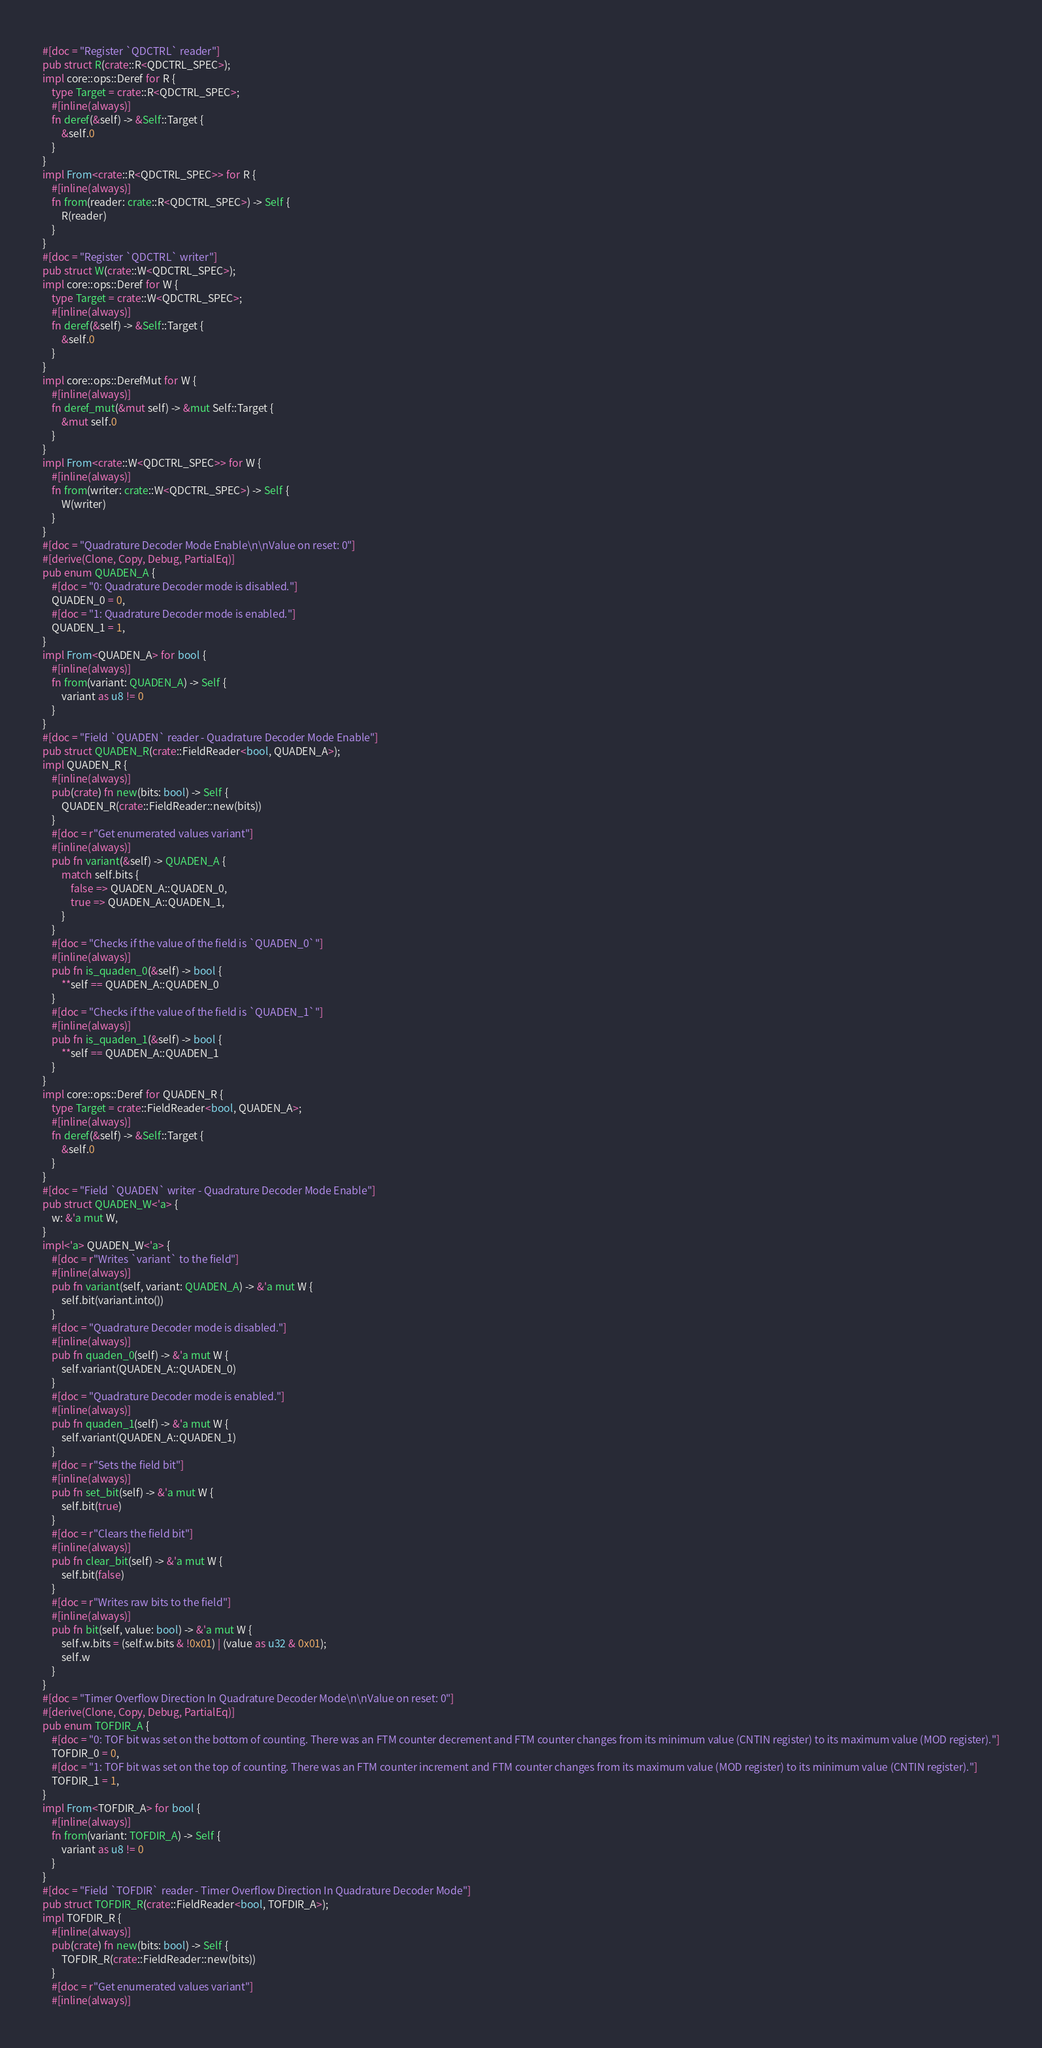Convert code to text. <code><loc_0><loc_0><loc_500><loc_500><_Rust_>#[doc = "Register `QDCTRL` reader"]
pub struct R(crate::R<QDCTRL_SPEC>);
impl core::ops::Deref for R {
    type Target = crate::R<QDCTRL_SPEC>;
    #[inline(always)]
    fn deref(&self) -> &Self::Target {
        &self.0
    }
}
impl From<crate::R<QDCTRL_SPEC>> for R {
    #[inline(always)]
    fn from(reader: crate::R<QDCTRL_SPEC>) -> Self {
        R(reader)
    }
}
#[doc = "Register `QDCTRL` writer"]
pub struct W(crate::W<QDCTRL_SPEC>);
impl core::ops::Deref for W {
    type Target = crate::W<QDCTRL_SPEC>;
    #[inline(always)]
    fn deref(&self) -> &Self::Target {
        &self.0
    }
}
impl core::ops::DerefMut for W {
    #[inline(always)]
    fn deref_mut(&mut self) -> &mut Self::Target {
        &mut self.0
    }
}
impl From<crate::W<QDCTRL_SPEC>> for W {
    #[inline(always)]
    fn from(writer: crate::W<QDCTRL_SPEC>) -> Self {
        W(writer)
    }
}
#[doc = "Quadrature Decoder Mode Enable\n\nValue on reset: 0"]
#[derive(Clone, Copy, Debug, PartialEq)]
pub enum QUADEN_A {
    #[doc = "0: Quadrature Decoder mode is disabled."]
    QUADEN_0 = 0,
    #[doc = "1: Quadrature Decoder mode is enabled."]
    QUADEN_1 = 1,
}
impl From<QUADEN_A> for bool {
    #[inline(always)]
    fn from(variant: QUADEN_A) -> Self {
        variant as u8 != 0
    }
}
#[doc = "Field `QUADEN` reader - Quadrature Decoder Mode Enable"]
pub struct QUADEN_R(crate::FieldReader<bool, QUADEN_A>);
impl QUADEN_R {
    #[inline(always)]
    pub(crate) fn new(bits: bool) -> Self {
        QUADEN_R(crate::FieldReader::new(bits))
    }
    #[doc = r"Get enumerated values variant"]
    #[inline(always)]
    pub fn variant(&self) -> QUADEN_A {
        match self.bits {
            false => QUADEN_A::QUADEN_0,
            true => QUADEN_A::QUADEN_1,
        }
    }
    #[doc = "Checks if the value of the field is `QUADEN_0`"]
    #[inline(always)]
    pub fn is_quaden_0(&self) -> bool {
        **self == QUADEN_A::QUADEN_0
    }
    #[doc = "Checks if the value of the field is `QUADEN_1`"]
    #[inline(always)]
    pub fn is_quaden_1(&self) -> bool {
        **self == QUADEN_A::QUADEN_1
    }
}
impl core::ops::Deref for QUADEN_R {
    type Target = crate::FieldReader<bool, QUADEN_A>;
    #[inline(always)]
    fn deref(&self) -> &Self::Target {
        &self.0
    }
}
#[doc = "Field `QUADEN` writer - Quadrature Decoder Mode Enable"]
pub struct QUADEN_W<'a> {
    w: &'a mut W,
}
impl<'a> QUADEN_W<'a> {
    #[doc = r"Writes `variant` to the field"]
    #[inline(always)]
    pub fn variant(self, variant: QUADEN_A) -> &'a mut W {
        self.bit(variant.into())
    }
    #[doc = "Quadrature Decoder mode is disabled."]
    #[inline(always)]
    pub fn quaden_0(self) -> &'a mut W {
        self.variant(QUADEN_A::QUADEN_0)
    }
    #[doc = "Quadrature Decoder mode is enabled."]
    #[inline(always)]
    pub fn quaden_1(self) -> &'a mut W {
        self.variant(QUADEN_A::QUADEN_1)
    }
    #[doc = r"Sets the field bit"]
    #[inline(always)]
    pub fn set_bit(self) -> &'a mut W {
        self.bit(true)
    }
    #[doc = r"Clears the field bit"]
    #[inline(always)]
    pub fn clear_bit(self) -> &'a mut W {
        self.bit(false)
    }
    #[doc = r"Writes raw bits to the field"]
    #[inline(always)]
    pub fn bit(self, value: bool) -> &'a mut W {
        self.w.bits = (self.w.bits & !0x01) | (value as u32 & 0x01);
        self.w
    }
}
#[doc = "Timer Overflow Direction In Quadrature Decoder Mode\n\nValue on reset: 0"]
#[derive(Clone, Copy, Debug, PartialEq)]
pub enum TOFDIR_A {
    #[doc = "0: TOF bit was set on the bottom of counting. There was an FTM counter decrement and FTM counter changes from its minimum value (CNTIN register) to its maximum value (MOD register)."]
    TOFDIR_0 = 0,
    #[doc = "1: TOF bit was set on the top of counting. There was an FTM counter increment and FTM counter changes from its maximum value (MOD register) to its minimum value (CNTIN register)."]
    TOFDIR_1 = 1,
}
impl From<TOFDIR_A> for bool {
    #[inline(always)]
    fn from(variant: TOFDIR_A) -> Self {
        variant as u8 != 0
    }
}
#[doc = "Field `TOFDIR` reader - Timer Overflow Direction In Quadrature Decoder Mode"]
pub struct TOFDIR_R(crate::FieldReader<bool, TOFDIR_A>);
impl TOFDIR_R {
    #[inline(always)]
    pub(crate) fn new(bits: bool) -> Self {
        TOFDIR_R(crate::FieldReader::new(bits))
    }
    #[doc = r"Get enumerated values variant"]
    #[inline(always)]</code> 